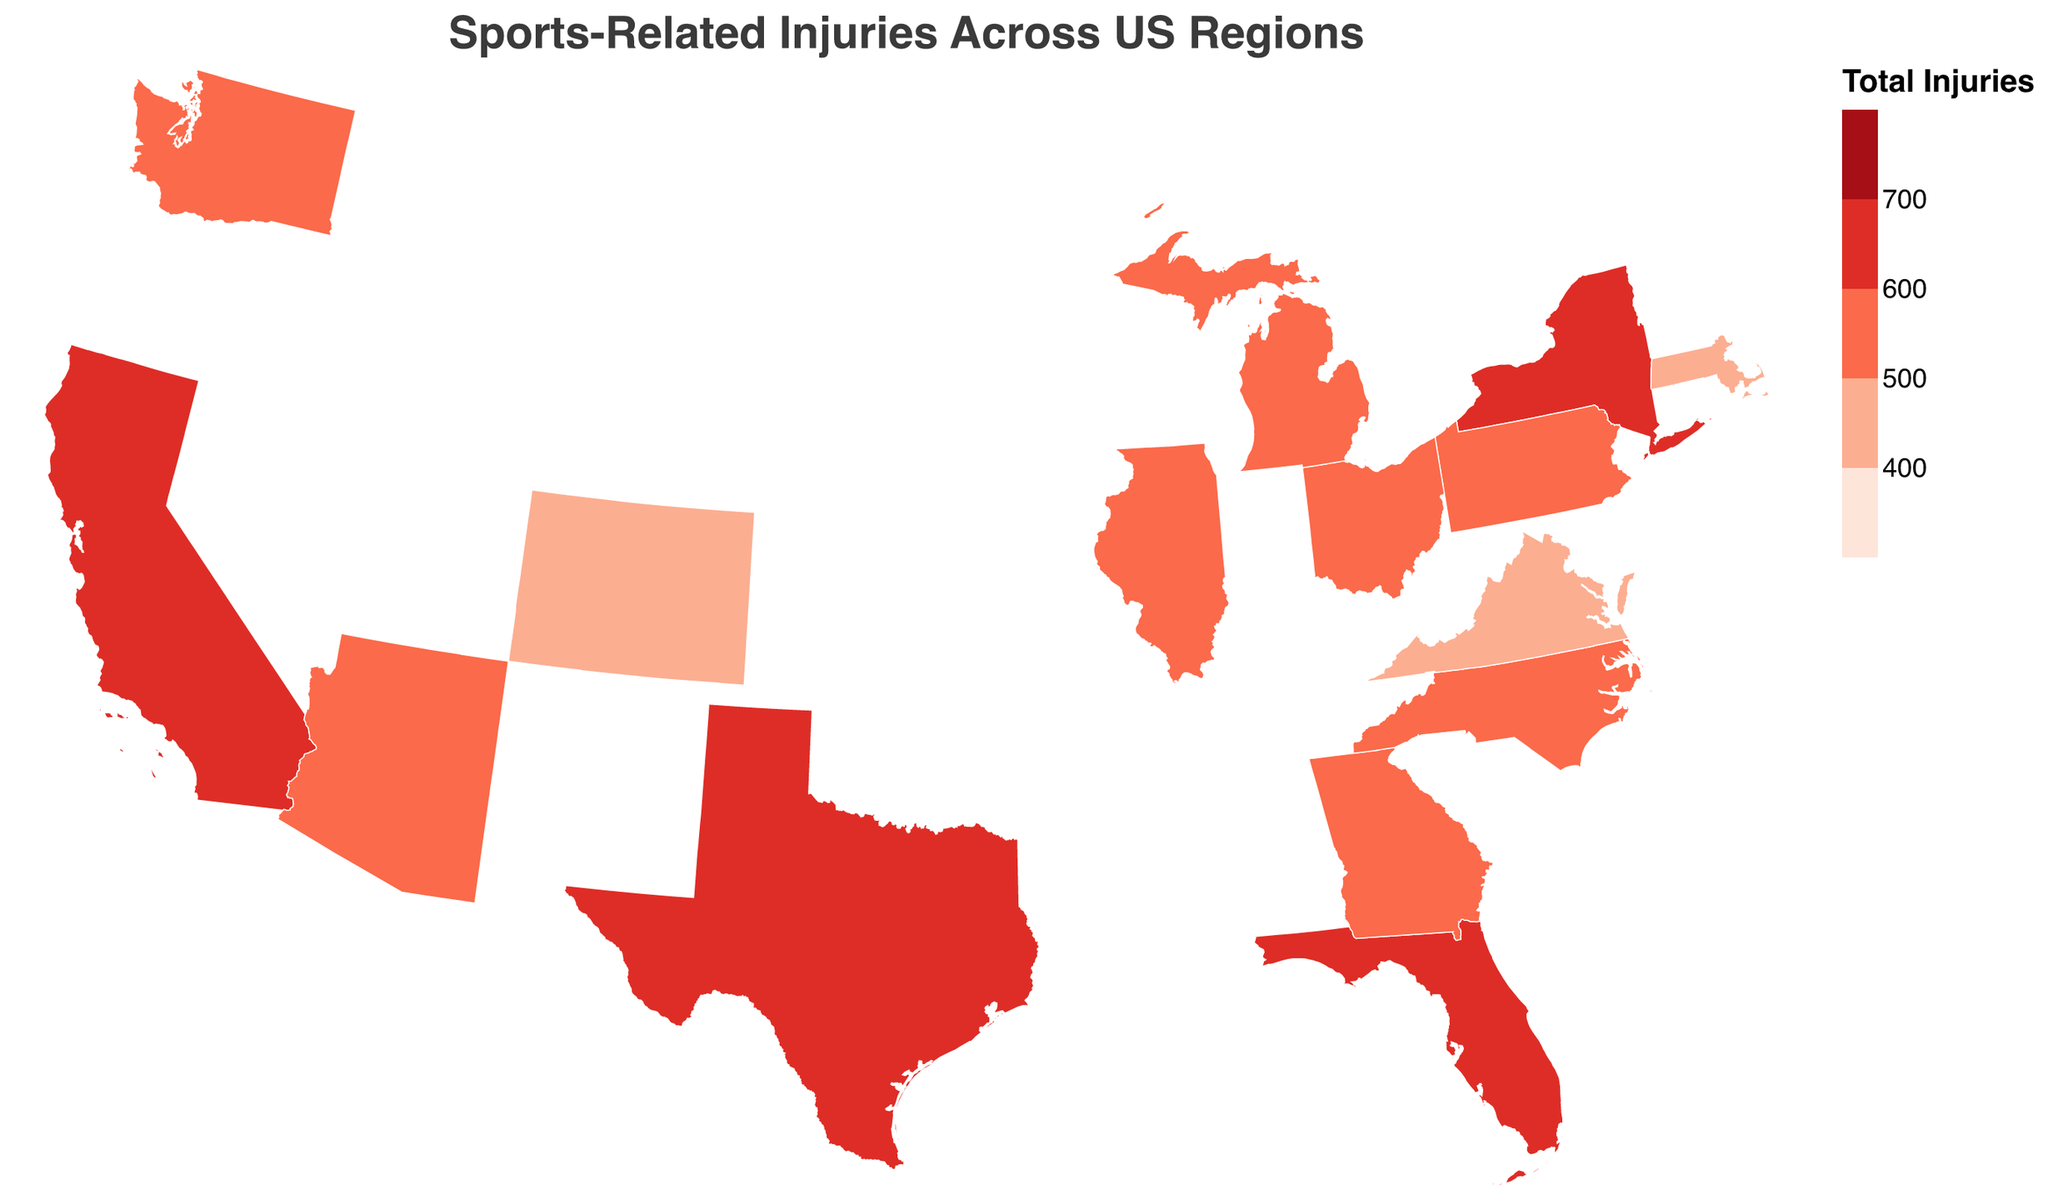How many total injuries are there in California? The tooltip for California shows values for Football, Basketball, Baseball, and Soccer injuries. Summing these: 245 + 180 + 135 + 110 = 670
Answer: 670 Which state has the fewest football injuries? Observing the color gradient, we look for the tooltip data of states with the least intense color. Sorting the states based on football injuries, Colorado has the fewest football injuries at 155.
Answer: Colorado Compare the basketball injuries in New York and Pennsylvania; which state has more and by how much? Pennsylvania has 155 basketball injuries, and New York has 210. The difference is 210 - 155 = 55.
Answer: New York by 55 What region seems to have the highest frequency of injuries overall? By summing the total injuries from each region in the tooltip, the South region has the highest with a combined total of Texas (660), Florida (690), and others.
Answer: South Does the Midwest region have fewer total injuries than the West region? Calculating total injuries for the Midwest: Illinois (555), Ohio (545), and Michigan (525) give us 555 + 545 + 525 = 1625. For the West: California (670), Washington (505), Arizona (550), and Colorado (480) total 670 + 505 + 550 + 480 = 2205. Midwest has fewer injuries than West.
Answer: Yes Which sport has the most injuries in Texas? According to the tooltip in the figure, Texas has 280 football injuries which are the highest among the listed sports.
Answer: Football Determine the average number of injuries across all sports in Massachusetts. The injuries in Massachusetts are Football (160), Basketball (140), Baseball (85), and Soccer (95). The total is 160 + 140 + 85 + 95 = 480. Average = 480 / 4 = 120.
Answer: 120 Are soccer injuries higher in Florida than in Ohio? From the tooltip data, Florida has 130 soccer injuries, and Ohio has 70 soccer injuries. Florida has more soccer injuries.
Answer: Yes What is the total number of injuries in the Northeast region? Summing the injuries for Massachusetts, New York, and Pennsylvania: 480 (MA) + 640 (NY) + 550 (PA) = 1670
Answer: 1670 